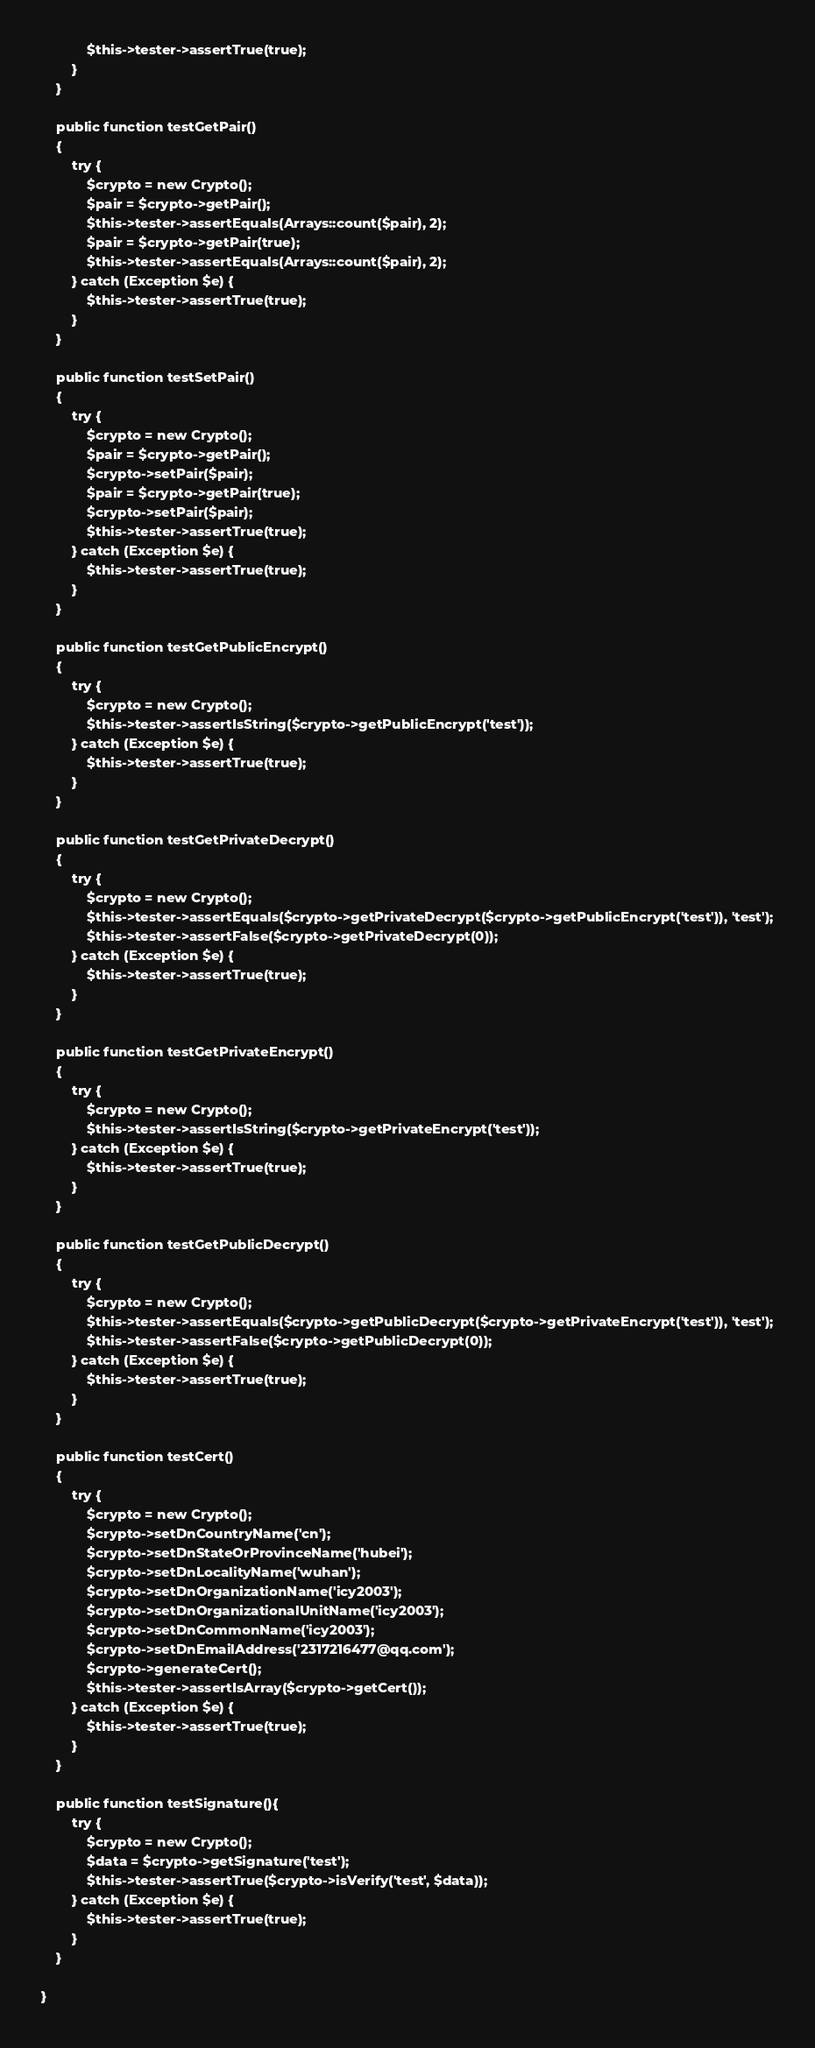<code> <loc_0><loc_0><loc_500><loc_500><_PHP_>            $this->tester->assertTrue(true);
        }
    }

    public function testGetPair()
    {
        try {
            $crypto = new Crypto();
            $pair = $crypto->getPair();
            $this->tester->assertEquals(Arrays::count($pair), 2);
            $pair = $crypto->getPair(true);
            $this->tester->assertEquals(Arrays::count($pair), 2);
        } catch (Exception $e) {
            $this->tester->assertTrue(true);
        }
    }

    public function testSetPair()
    {
        try {
            $crypto = new Crypto();
            $pair = $crypto->getPair();
            $crypto->setPair($pair);
            $pair = $crypto->getPair(true);
            $crypto->setPair($pair);
            $this->tester->assertTrue(true);
        } catch (Exception $e) {
            $this->tester->assertTrue(true);
        }
    }

    public function testGetPublicEncrypt()
    {
        try {
            $crypto = new Crypto();
            $this->tester->assertIsString($crypto->getPublicEncrypt('test'));
        } catch (Exception $e) {
            $this->tester->assertTrue(true);
        }
    }

    public function testGetPrivateDecrypt()
    {
        try {
            $crypto = new Crypto();
            $this->tester->assertEquals($crypto->getPrivateDecrypt($crypto->getPublicEncrypt('test')), 'test');
            $this->tester->assertFalse($crypto->getPrivateDecrypt(0));
        } catch (Exception $e) {
            $this->tester->assertTrue(true);
        }
    }

    public function testGetPrivateEncrypt()
    {
        try {
            $crypto = new Crypto();
            $this->tester->assertIsString($crypto->getPrivateEncrypt('test'));
        } catch (Exception $e) {
            $this->tester->assertTrue(true);
        }
    }

    public function testGetPublicDecrypt()
    {
        try {
            $crypto = new Crypto();
            $this->tester->assertEquals($crypto->getPublicDecrypt($crypto->getPrivateEncrypt('test')), 'test');
            $this->tester->assertFalse($crypto->getPublicDecrypt(0));
        } catch (Exception $e) {
            $this->tester->assertTrue(true);
        }
    }

    public function testCert()
    {
        try {
            $crypto = new Crypto();
            $crypto->setDnCountryName('cn');
            $crypto->setDnStateOrProvinceName('hubei');
            $crypto->setDnLocalityName('wuhan');
            $crypto->setDnOrganizationName('icy2003');
            $crypto->setDnOrganizationalUnitName('icy2003');
            $crypto->setDnCommonName('icy2003');
            $crypto->setDnEmailAddress('2317216477@qq.com');
            $crypto->generateCert();
            $this->tester->assertIsArray($crypto->getCert());
        } catch (Exception $e) {
            $this->tester->assertTrue(true);
        }
    }

    public function testSignature(){
        try {
            $crypto = new Crypto();
            $data = $crypto->getSignature('test');
            $this->tester->assertTrue($crypto->isVerify('test', $data));
        } catch (Exception $e) {
            $this->tester->assertTrue(true);
        }
    }

}
</code> 